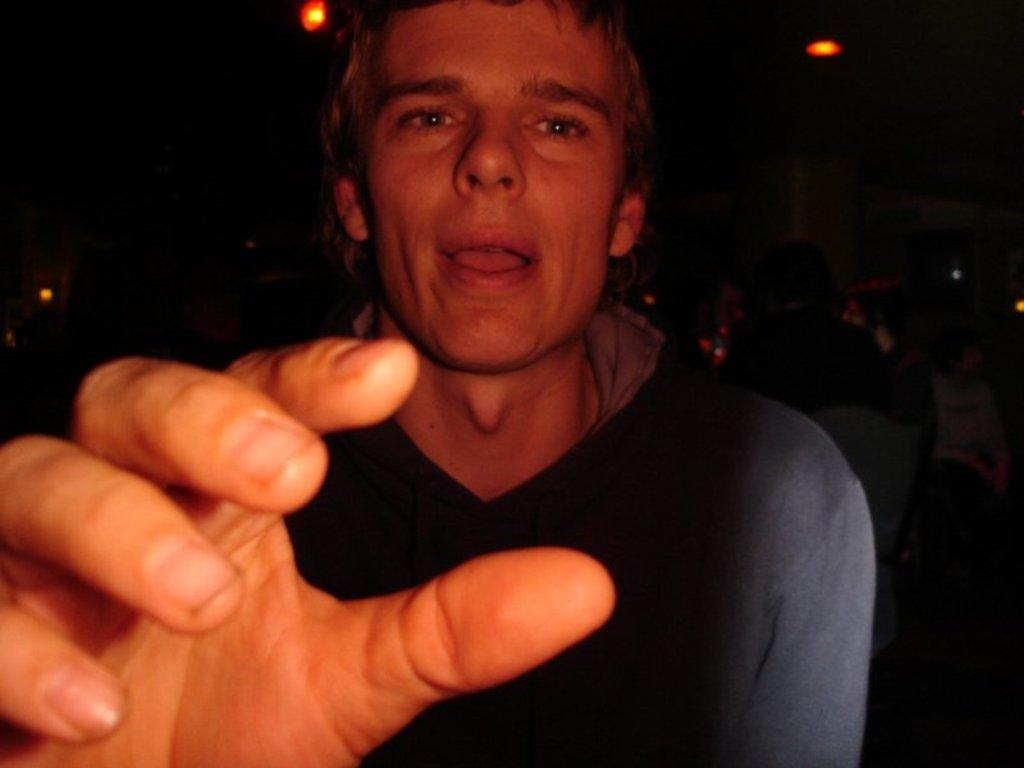Who is present in the image? There is a man in the image. What is the man wearing? The man is wearing a T-shirt. Can you describe the person in the background of the image? There is a person sitting on a chair in the background of the image. What can be seen in the image that provides illumination? There are lights visible in the image. How many jellyfish are swimming in the image? There are no jellyfish present in the image. What type of watch is the man wearing in the image? The man is not wearing a watch in the image. 